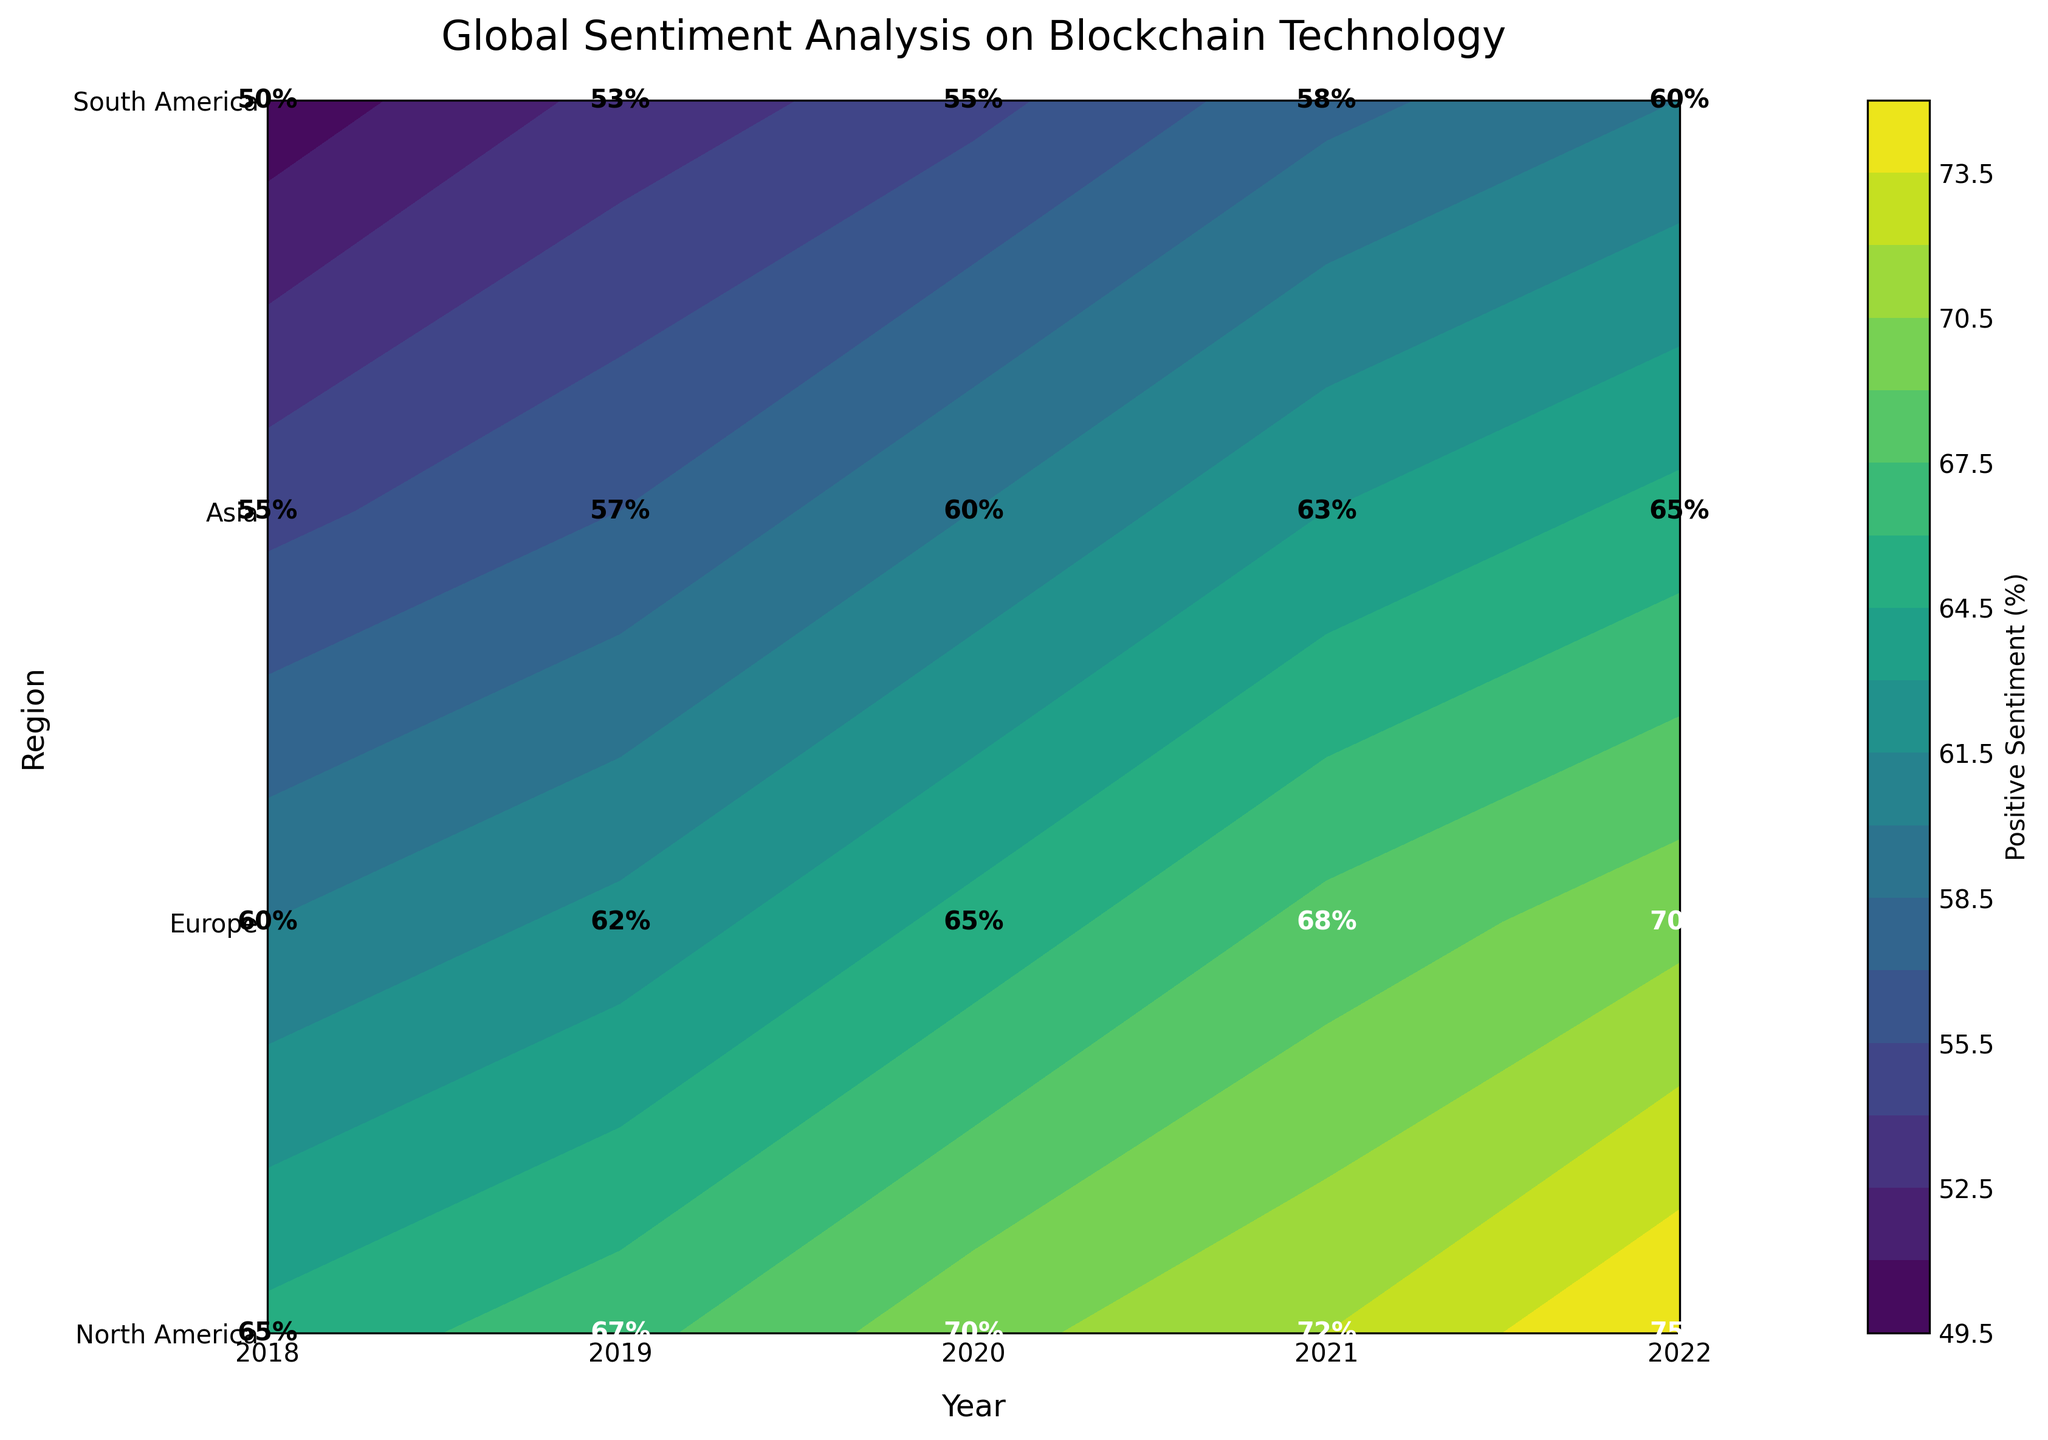What is the title of the plot? The title is displayed at the top of the plot. It reads "Global Sentiment Analysis on Blockchain Technology".
Answer: Global Sentiment Analysis on Blockchain Technology Which region had the highest positive sentiment in 2022? On the 2022 column, locate the region with the highest percentage value. North America shows 75%, which is the highest.
Answer: North America How did the positive sentiment in Europe change from 2018 to 2022? Find the values for Europe from 2018 to 2022. They increase from 60% (2018) to 70% (2022).
Answer: Increased from 60% to 70% Compare the positive sentiment in North America and Asia in 2020. Which region had a higher percentage? Look at the values for 2020. North America has 70%, while Asia has 60%. North America is higher.
Answer: North America What is the range of positive sentiment percentages displayed on the color bar? The color bar on the right side of the plot indicates the range. It starts at 50% and ends at 75%.
Answer: 50% to 75% How many unique regions are represented in the plot? The y-axis labels each region. Counting them, there are four: North America, Europe, Asia, and South America.
Answer: Four In which region and year was the minimum positive sentiment observed? Examine all the values in the plot. The minimum is 50%, seen in South America in 2018.
Answer: South America, 2018 Calculate the average positive sentiment in North America over the given years. Add the values for North America from 2018 to 2022 (65 + 67 + 70 + 72 + 75) and divide by 5. The average is 69.8%.
Answer: 69.8% Which year showed the most substantial increase in positive sentiment in Asia? Compare consecutive years for Asia. The increase from 2019 (57%) to 2020 (60%) is the highest at 3%.
Answer: 2019 to 2020 Does the overall positive sentiment show an increasing or decreasing trend over the years for all regions? Observing the values for all regions, we see an increasing trend for each region from 2018 to 2022.
Answer: Increasing 